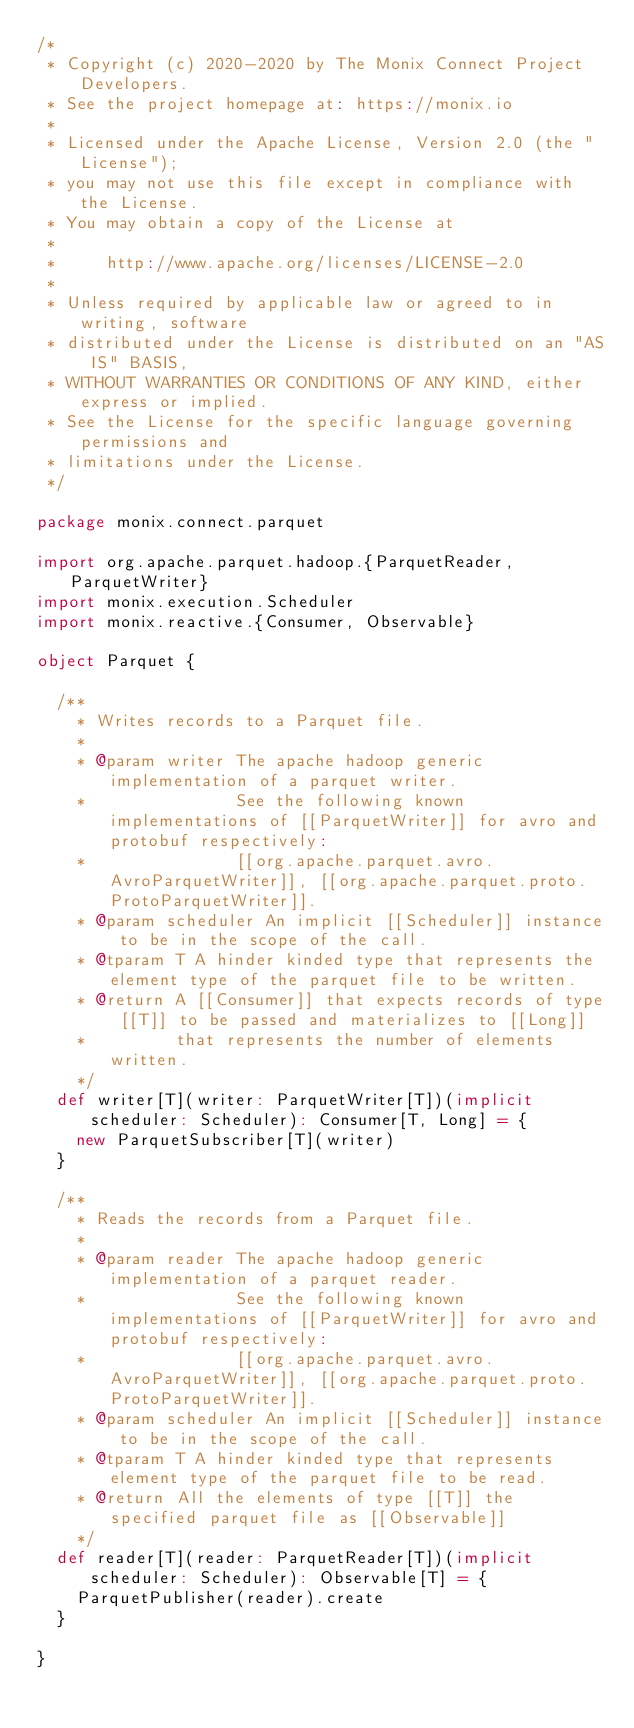<code> <loc_0><loc_0><loc_500><loc_500><_Scala_>/*
 * Copyright (c) 2020-2020 by The Monix Connect Project Developers.
 * See the project homepage at: https://monix.io
 *
 * Licensed under the Apache License, Version 2.0 (the "License");
 * you may not use this file except in compliance with the License.
 * You may obtain a copy of the License at
 *
 *     http://www.apache.org/licenses/LICENSE-2.0
 *
 * Unless required by applicable law or agreed to in writing, software
 * distributed under the License is distributed on an "AS IS" BASIS,
 * WITHOUT WARRANTIES OR CONDITIONS OF ANY KIND, either express or implied.
 * See the License for the specific language governing permissions and
 * limitations under the License.
 */

package monix.connect.parquet

import org.apache.parquet.hadoop.{ParquetReader, ParquetWriter}
import monix.execution.Scheduler
import monix.reactive.{Consumer, Observable}

object Parquet {

  /**
    * Writes records to a Parquet file.
    *
    * @param writer The apache hadoop generic implementation of a parquet writer.
    *               See the following known implementations of [[ParquetWriter]] for avro and protobuf respectively:
    *               [[org.apache.parquet.avro.AvroParquetWriter]], [[org.apache.parquet.proto.ProtoParquetWriter]].
    * @param scheduler An implicit [[Scheduler]] instance to be in the scope of the call.
    * @tparam T A hinder kinded type that represents the element type of the parquet file to be written.
    * @return A [[Consumer]] that expects records of type [[T]] to be passed and materializes to [[Long]]
    *         that represents the number of elements written.
    */
  def writer[T](writer: ParquetWriter[T])(implicit scheduler: Scheduler): Consumer[T, Long] = {
    new ParquetSubscriber[T](writer)
  }

  /**
    * Reads the records from a Parquet file.
    *
    * @param reader The apache hadoop generic implementation of a parquet reader.
    *               See the following known implementations of [[ParquetWriter]] for avro and protobuf respectively:
    *               [[org.apache.parquet.avro.AvroParquetWriter]], [[org.apache.parquet.proto.ProtoParquetWriter]].
    * @param scheduler An implicit [[Scheduler]] instance to be in the scope of the call.
    * @tparam T A hinder kinded type that represents element type of the parquet file to be read.
    * @return All the elements of type [[T]] the specified parquet file as [[Observable]]
    */
  def reader[T](reader: ParquetReader[T])(implicit scheduler: Scheduler): Observable[T] = {
    ParquetPublisher(reader).create
  }

}
</code> 